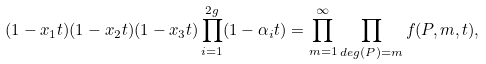Convert formula to latex. <formula><loc_0><loc_0><loc_500><loc_500>( 1 - x _ { 1 } t ) ( 1 - x _ { 2 } t ) ( 1 - x _ { 3 } t ) \prod _ { i = 1 } ^ { 2 g } ( 1 - \alpha _ { i } t ) = \prod _ { m = 1 } ^ { \infty } \prod _ { d e g ( P ) = m } f ( P , m , t ) ,</formula> 